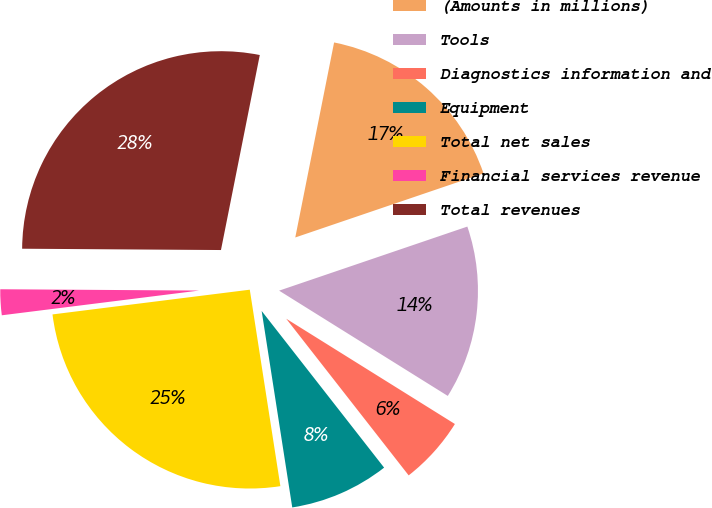<chart> <loc_0><loc_0><loc_500><loc_500><pie_chart><fcel>(Amounts in millions)<fcel>Tools<fcel>Diagnostics information and<fcel>Equipment<fcel>Total net sales<fcel>Financial services revenue<fcel>Total revenues<nl><fcel>16.65%<fcel>14.1%<fcel>5.56%<fcel>8.1%<fcel>25.47%<fcel>2.09%<fcel>28.02%<nl></chart> 